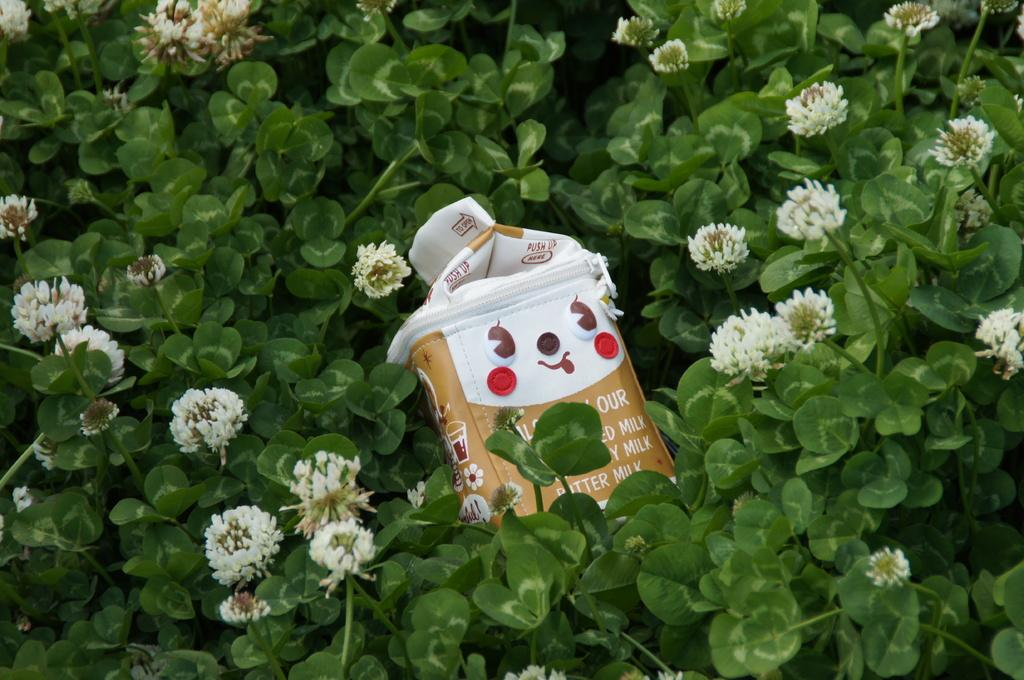What object is present in the image that might be used for carrying items? There is a bag in the image that might be used for carrying items. Where is the bag located in relation to the plants? The bag is located between plants in the image. What feature of the plants can be observed? The plants have flowers. What type of alarm can be heard going off in the image? There is no alarm present in the image, and therefore no sound can be heard. 